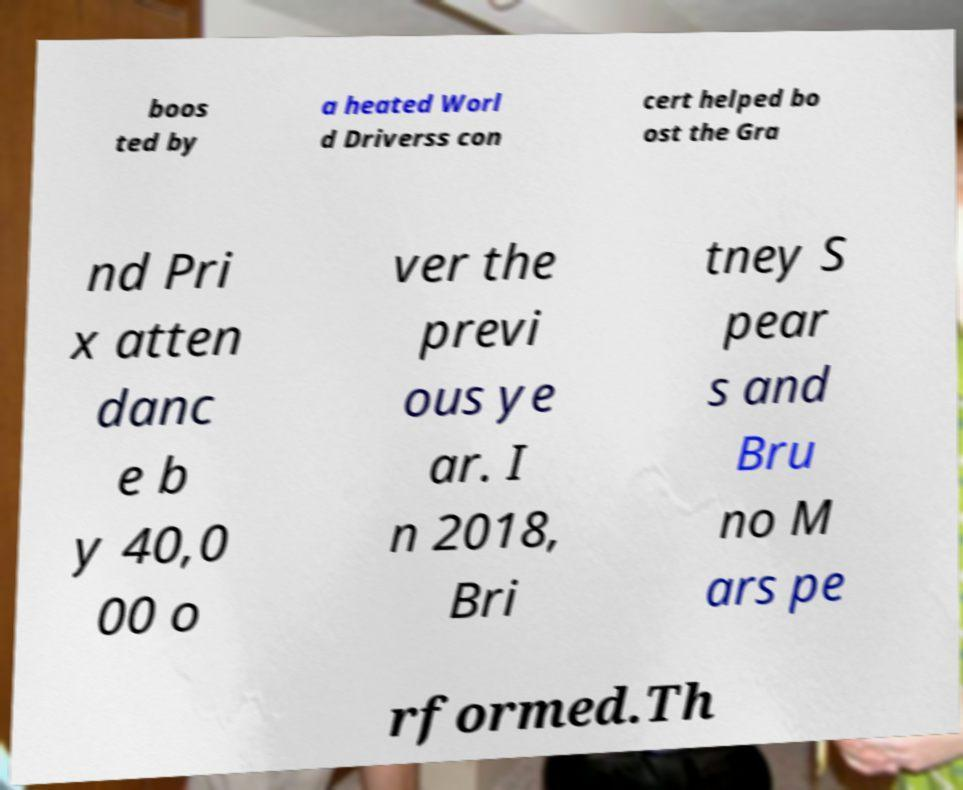What messages or text are displayed in this image? I need them in a readable, typed format. boos ted by a heated Worl d Driverss con cert helped bo ost the Gra nd Pri x atten danc e b y 40,0 00 o ver the previ ous ye ar. I n 2018, Bri tney S pear s and Bru no M ars pe rformed.Th 